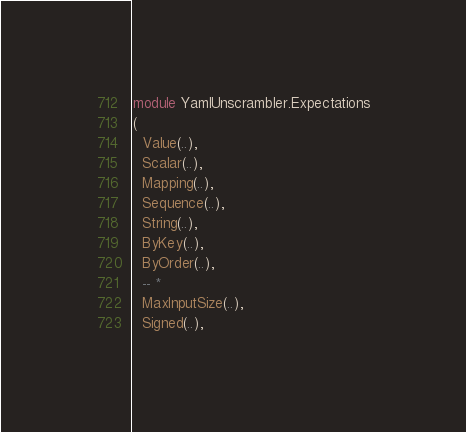Convert code to text. <code><loc_0><loc_0><loc_500><loc_500><_Haskell_>module YamlUnscrambler.Expectations
(
  Value(..),
  Scalar(..),
  Mapping(..),
  Sequence(..),
  String(..),
  ByKey(..),
  ByOrder(..),
  -- *
  MaxInputSize(..),
  Signed(..),</code> 